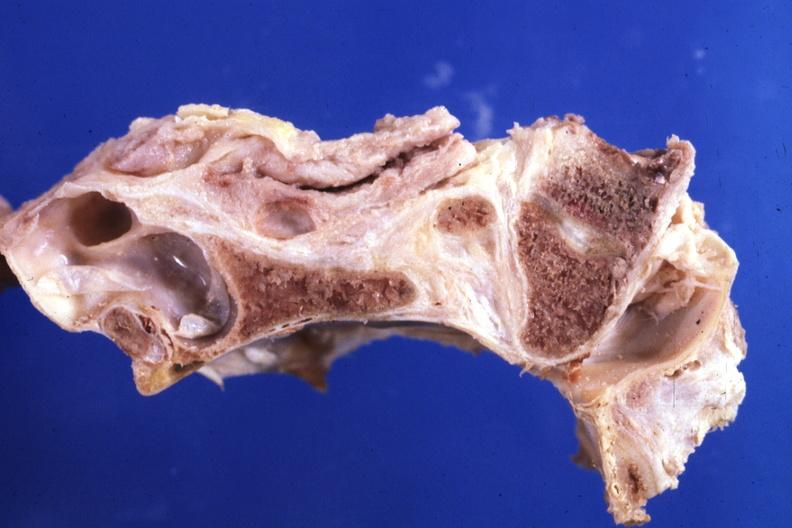what is present?
Answer the question using a single word or phrase. Bone 